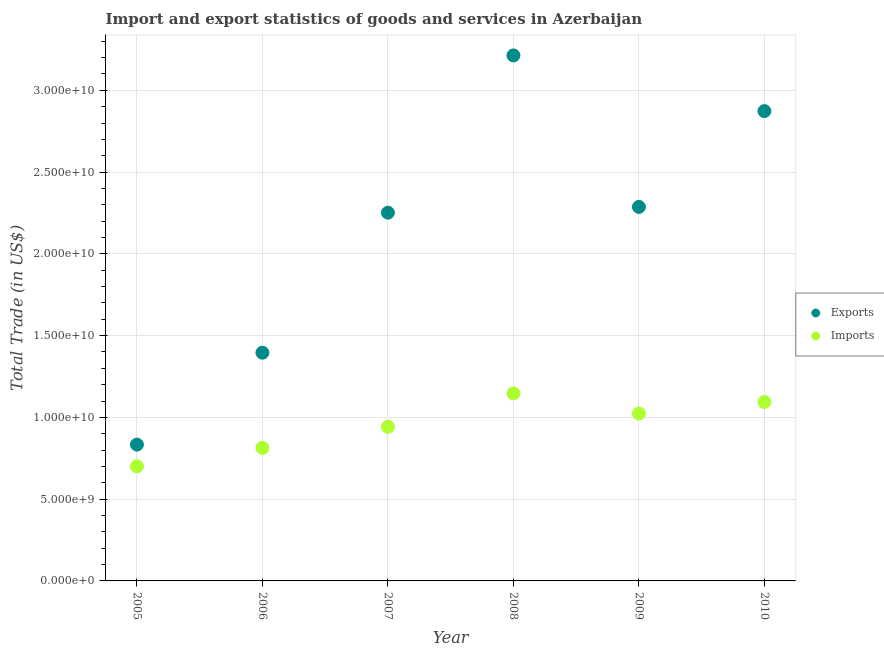Is the number of dotlines equal to the number of legend labels?
Provide a short and direct response. Yes. What is the imports of goods and services in 2006?
Ensure brevity in your answer.  8.13e+09. Across all years, what is the maximum export of goods and services?
Your answer should be compact. 3.21e+1. Across all years, what is the minimum imports of goods and services?
Your answer should be compact. 7.01e+09. In which year was the imports of goods and services maximum?
Provide a succinct answer. 2008. In which year was the imports of goods and services minimum?
Provide a short and direct response. 2005. What is the total export of goods and services in the graph?
Make the answer very short. 1.29e+11. What is the difference between the imports of goods and services in 2006 and that in 2007?
Your answer should be compact. -1.29e+09. What is the difference between the export of goods and services in 2010 and the imports of goods and services in 2005?
Offer a terse response. 2.17e+1. What is the average imports of goods and services per year?
Your answer should be compact. 9.53e+09. In the year 2009, what is the difference between the imports of goods and services and export of goods and services?
Your answer should be compact. -1.26e+1. What is the ratio of the imports of goods and services in 2008 to that in 2009?
Your response must be concise. 1.12. Is the imports of goods and services in 2008 less than that in 2009?
Your answer should be very brief. No. What is the difference between the highest and the second highest imports of goods and services?
Your answer should be compact. 5.23e+08. What is the difference between the highest and the lowest imports of goods and services?
Keep it short and to the point. 4.46e+09. In how many years, is the export of goods and services greater than the average export of goods and services taken over all years?
Ensure brevity in your answer.  4. Is the export of goods and services strictly greater than the imports of goods and services over the years?
Your answer should be very brief. Yes. What is the title of the graph?
Make the answer very short. Import and export statistics of goods and services in Azerbaijan. What is the label or title of the X-axis?
Make the answer very short. Year. What is the label or title of the Y-axis?
Offer a terse response. Total Trade (in US$). What is the Total Trade (in US$) of Exports in 2005?
Your answer should be compact. 8.34e+09. What is the Total Trade (in US$) in Imports in 2005?
Make the answer very short. 7.01e+09. What is the Total Trade (in US$) in Exports in 2006?
Your response must be concise. 1.40e+1. What is the Total Trade (in US$) in Imports in 2006?
Keep it short and to the point. 8.13e+09. What is the Total Trade (in US$) in Exports in 2007?
Provide a succinct answer. 2.25e+1. What is the Total Trade (in US$) of Imports in 2007?
Give a very brief answer. 9.42e+09. What is the Total Trade (in US$) in Exports in 2008?
Provide a short and direct response. 3.21e+1. What is the Total Trade (in US$) of Imports in 2008?
Give a very brief answer. 1.15e+1. What is the Total Trade (in US$) in Exports in 2009?
Make the answer very short. 2.29e+1. What is the Total Trade (in US$) in Imports in 2009?
Your answer should be very brief. 1.02e+1. What is the Total Trade (in US$) of Exports in 2010?
Offer a terse response. 2.87e+1. What is the Total Trade (in US$) in Imports in 2010?
Provide a succinct answer. 1.09e+1. Across all years, what is the maximum Total Trade (in US$) in Exports?
Provide a succinct answer. 3.21e+1. Across all years, what is the maximum Total Trade (in US$) in Imports?
Provide a succinct answer. 1.15e+1. Across all years, what is the minimum Total Trade (in US$) in Exports?
Make the answer very short. 8.34e+09. Across all years, what is the minimum Total Trade (in US$) in Imports?
Provide a succinct answer. 7.01e+09. What is the total Total Trade (in US$) in Exports in the graph?
Offer a very short reply. 1.29e+11. What is the total Total Trade (in US$) of Imports in the graph?
Keep it short and to the point. 5.72e+1. What is the difference between the Total Trade (in US$) in Exports in 2005 and that in 2006?
Make the answer very short. -5.62e+09. What is the difference between the Total Trade (in US$) of Imports in 2005 and that in 2006?
Provide a succinct answer. -1.13e+09. What is the difference between the Total Trade (in US$) of Exports in 2005 and that in 2007?
Your answer should be very brief. -1.42e+1. What is the difference between the Total Trade (in US$) of Imports in 2005 and that in 2007?
Give a very brief answer. -2.42e+09. What is the difference between the Total Trade (in US$) of Exports in 2005 and that in 2008?
Offer a terse response. -2.38e+1. What is the difference between the Total Trade (in US$) in Imports in 2005 and that in 2008?
Keep it short and to the point. -4.46e+09. What is the difference between the Total Trade (in US$) in Exports in 2005 and that in 2009?
Ensure brevity in your answer.  -1.45e+1. What is the difference between the Total Trade (in US$) in Imports in 2005 and that in 2009?
Offer a very short reply. -3.23e+09. What is the difference between the Total Trade (in US$) in Exports in 2005 and that in 2010?
Offer a terse response. -2.04e+1. What is the difference between the Total Trade (in US$) in Imports in 2005 and that in 2010?
Your answer should be compact. -3.93e+09. What is the difference between the Total Trade (in US$) in Exports in 2006 and that in 2007?
Your answer should be compact. -8.56e+09. What is the difference between the Total Trade (in US$) in Imports in 2006 and that in 2007?
Provide a short and direct response. -1.29e+09. What is the difference between the Total Trade (in US$) in Exports in 2006 and that in 2008?
Your answer should be compact. -1.82e+1. What is the difference between the Total Trade (in US$) in Imports in 2006 and that in 2008?
Provide a succinct answer. -3.33e+09. What is the difference between the Total Trade (in US$) in Exports in 2006 and that in 2009?
Your answer should be compact. -8.92e+09. What is the difference between the Total Trade (in US$) of Imports in 2006 and that in 2009?
Your answer should be very brief. -2.10e+09. What is the difference between the Total Trade (in US$) in Exports in 2006 and that in 2010?
Give a very brief answer. -1.48e+1. What is the difference between the Total Trade (in US$) of Imports in 2006 and that in 2010?
Offer a terse response. -2.81e+09. What is the difference between the Total Trade (in US$) in Exports in 2007 and that in 2008?
Give a very brief answer. -9.62e+09. What is the difference between the Total Trade (in US$) in Imports in 2007 and that in 2008?
Your answer should be very brief. -2.04e+09. What is the difference between the Total Trade (in US$) in Exports in 2007 and that in 2009?
Your answer should be compact. -3.53e+08. What is the difference between the Total Trade (in US$) of Imports in 2007 and that in 2009?
Your answer should be very brief. -8.11e+08. What is the difference between the Total Trade (in US$) of Exports in 2007 and that in 2010?
Offer a terse response. -6.21e+09. What is the difference between the Total Trade (in US$) of Imports in 2007 and that in 2010?
Make the answer very short. -1.52e+09. What is the difference between the Total Trade (in US$) of Exports in 2008 and that in 2009?
Provide a succinct answer. 9.26e+09. What is the difference between the Total Trade (in US$) in Imports in 2008 and that in 2009?
Give a very brief answer. 1.23e+09. What is the difference between the Total Trade (in US$) in Exports in 2008 and that in 2010?
Offer a terse response. 3.40e+09. What is the difference between the Total Trade (in US$) of Imports in 2008 and that in 2010?
Keep it short and to the point. 5.23e+08. What is the difference between the Total Trade (in US$) in Exports in 2009 and that in 2010?
Your answer should be very brief. -5.86e+09. What is the difference between the Total Trade (in US$) in Imports in 2009 and that in 2010?
Offer a terse response. -7.06e+08. What is the difference between the Total Trade (in US$) of Exports in 2005 and the Total Trade (in US$) of Imports in 2006?
Provide a short and direct response. 2.03e+08. What is the difference between the Total Trade (in US$) in Exports in 2005 and the Total Trade (in US$) in Imports in 2007?
Your answer should be very brief. -1.09e+09. What is the difference between the Total Trade (in US$) of Exports in 2005 and the Total Trade (in US$) of Imports in 2008?
Offer a terse response. -3.13e+09. What is the difference between the Total Trade (in US$) of Exports in 2005 and the Total Trade (in US$) of Imports in 2009?
Your answer should be compact. -1.90e+09. What is the difference between the Total Trade (in US$) in Exports in 2005 and the Total Trade (in US$) in Imports in 2010?
Your answer should be very brief. -2.60e+09. What is the difference between the Total Trade (in US$) in Exports in 2006 and the Total Trade (in US$) in Imports in 2007?
Give a very brief answer. 4.53e+09. What is the difference between the Total Trade (in US$) in Exports in 2006 and the Total Trade (in US$) in Imports in 2008?
Your answer should be very brief. 2.49e+09. What is the difference between the Total Trade (in US$) in Exports in 2006 and the Total Trade (in US$) in Imports in 2009?
Offer a terse response. 3.72e+09. What is the difference between the Total Trade (in US$) of Exports in 2006 and the Total Trade (in US$) of Imports in 2010?
Provide a succinct answer. 3.01e+09. What is the difference between the Total Trade (in US$) in Exports in 2007 and the Total Trade (in US$) in Imports in 2008?
Your response must be concise. 1.11e+1. What is the difference between the Total Trade (in US$) of Exports in 2007 and the Total Trade (in US$) of Imports in 2009?
Your answer should be very brief. 1.23e+1. What is the difference between the Total Trade (in US$) of Exports in 2007 and the Total Trade (in US$) of Imports in 2010?
Provide a short and direct response. 1.16e+1. What is the difference between the Total Trade (in US$) in Exports in 2008 and the Total Trade (in US$) in Imports in 2009?
Offer a terse response. 2.19e+1. What is the difference between the Total Trade (in US$) of Exports in 2008 and the Total Trade (in US$) of Imports in 2010?
Offer a terse response. 2.12e+1. What is the difference between the Total Trade (in US$) of Exports in 2009 and the Total Trade (in US$) of Imports in 2010?
Offer a terse response. 1.19e+1. What is the average Total Trade (in US$) in Exports per year?
Offer a terse response. 2.14e+1. What is the average Total Trade (in US$) of Imports per year?
Ensure brevity in your answer.  9.53e+09. In the year 2005, what is the difference between the Total Trade (in US$) of Exports and Total Trade (in US$) of Imports?
Provide a succinct answer. 1.33e+09. In the year 2006, what is the difference between the Total Trade (in US$) in Exports and Total Trade (in US$) in Imports?
Offer a terse response. 5.82e+09. In the year 2007, what is the difference between the Total Trade (in US$) of Exports and Total Trade (in US$) of Imports?
Provide a succinct answer. 1.31e+1. In the year 2008, what is the difference between the Total Trade (in US$) in Exports and Total Trade (in US$) in Imports?
Keep it short and to the point. 2.07e+1. In the year 2009, what is the difference between the Total Trade (in US$) in Exports and Total Trade (in US$) in Imports?
Make the answer very short. 1.26e+1. In the year 2010, what is the difference between the Total Trade (in US$) in Exports and Total Trade (in US$) in Imports?
Ensure brevity in your answer.  1.78e+1. What is the ratio of the Total Trade (in US$) of Exports in 2005 to that in 2006?
Give a very brief answer. 0.6. What is the ratio of the Total Trade (in US$) in Imports in 2005 to that in 2006?
Keep it short and to the point. 0.86. What is the ratio of the Total Trade (in US$) in Exports in 2005 to that in 2007?
Give a very brief answer. 0.37. What is the ratio of the Total Trade (in US$) of Imports in 2005 to that in 2007?
Offer a terse response. 0.74. What is the ratio of the Total Trade (in US$) in Exports in 2005 to that in 2008?
Offer a terse response. 0.26. What is the ratio of the Total Trade (in US$) in Imports in 2005 to that in 2008?
Offer a very short reply. 0.61. What is the ratio of the Total Trade (in US$) in Exports in 2005 to that in 2009?
Offer a very short reply. 0.36. What is the ratio of the Total Trade (in US$) in Imports in 2005 to that in 2009?
Your response must be concise. 0.68. What is the ratio of the Total Trade (in US$) in Exports in 2005 to that in 2010?
Make the answer very short. 0.29. What is the ratio of the Total Trade (in US$) of Imports in 2005 to that in 2010?
Provide a succinct answer. 0.64. What is the ratio of the Total Trade (in US$) of Exports in 2006 to that in 2007?
Ensure brevity in your answer.  0.62. What is the ratio of the Total Trade (in US$) in Imports in 2006 to that in 2007?
Provide a short and direct response. 0.86. What is the ratio of the Total Trade (in US$) in Exports in 2006 to that in 2008?
Your answer should be compact. 0.43. What is the ratio of the Total Trade (in US$) in Imports in 2006 to that in 2008?
Offer a very short reply. 0.71. What is the ratio of the Total Trade (in US$) in Exports in 2006 to that in 2009?
Offer a terse response. 0.61. What is the ratio of the Total Trade (in US$) in Imports in 2006 to that in 2009?
Your answer should be compact. 0.79. What is the ratio of the Total Trade (in US$) of Exports in 2006 to that in 2010?
Your answer should be very brief. 0.49. What is the ratio of the Total Trade (in US$) of Imports in 2006 to that in 2010?
Your response must be concise. 0.74. What is the ratio of the Total Trade (in US$) of Exports in 2007 to that in 2008?
Your answer should be very brief. 0.7. What is the ratio of the Total Trade (in US$) in Imports in 2007 to that in 2008?
Offer a very short reply. 0.82. What is the ratio of the Total Trade (in US$) in Exports in 2007 to that in 2009?
Your response must be concise. 0.98. What is the ratio of the Total Trade (in US$) in Imports in 2007 to that in 2009?
Your answer should be compact. 0.92. What is the ratio of the Total Trade (in US$) of Exports in 2007 to that in 2010?
Keep it short and to the point. 0.78. What is the ratio of the Total Trade (in US$) of Imports in 2007 to that in 2010?
Your response must be concise. 0.86. What is the ratio of the Total Trade (in US$) in Exports in 2008 to that in 2009?
Provide a succinct answer. 1.41. What is the ratio of the Total Trade (in US$) in Imports in 2008 to that in 2009?
Your answer should be very brief. 1.12. What is the ratio of the Total Trade (in US$) in Exports in 2008 to that in 2010?
Ensure brevity in your answer.  1.12. What is the ratio of the Total Trade (in US$) of Imports in 2008 to that in 2010?
Offer a terse response. 1.05. What is the ratio of the Total Trade (in US$) of Exports in 2009 to that in 2010?
Give a very brief answer. 0.8. What is the ratio of the Total Trade (in US$) in Imports in 2009 to that in 2010?
Provide a succinct answer. 0.94. What is the difference between the highest and the second highest Total Trade (in US$) in Exports?
Provide a short and direct response. 3.40e+09. What is the difference between the highest and the second highest Total Trade (in US$) in Imports?
Your answer should be compact. 5.23e+08. What is the difference between the highest and the lowest Total Trade (in US$) in Exports?
Make the answer very short. 2.38e+1. What is the difference between the highest and the lowest Total Trade (in US$) of Imports?
Your response must be concise. 4.46e+09. 